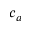<formula> <loc_0><loc_0><loc_500><loc_500>c _ { a }</formula> 